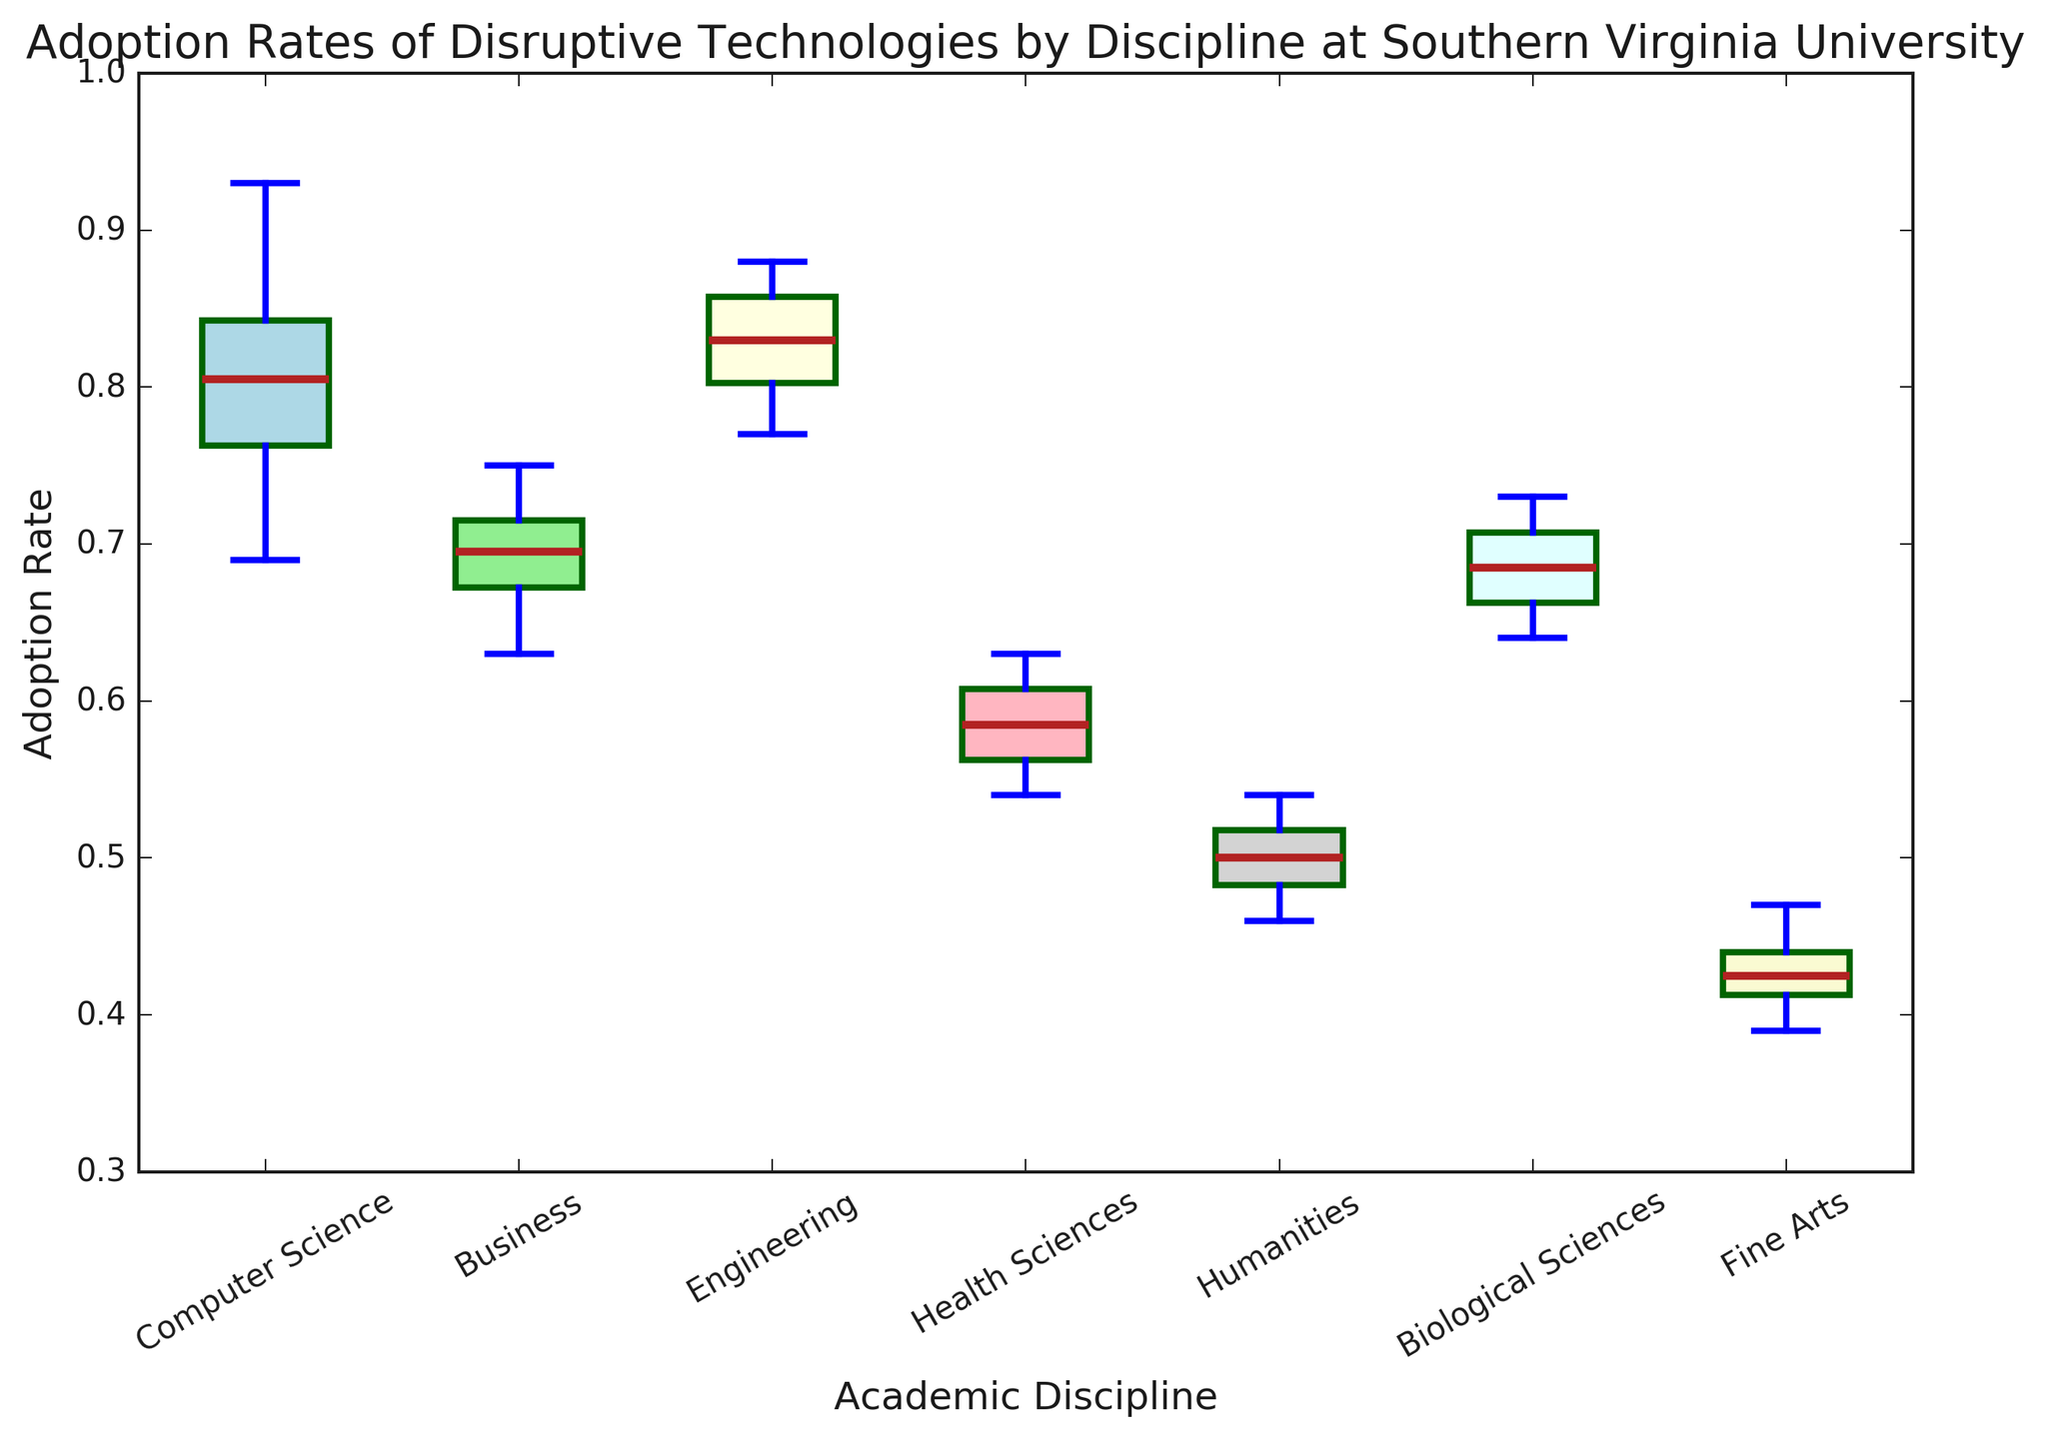Which academic discipline has the highest median adoption rate? By looking at the plot, find the median line for each box plot and compare their positions. The highest median is represented by the line in the Engineering box plot.
Answer: Engineering Which academic discipline has the lowest lower whisker? By observing all the whiskers of each box plot, the lowest whisker is visibly in the Fine Arts box plot.
Answer: Fine Arts What is the range of adoption rates in the Health Sciences discipline? The range is the difference between the top whisker and the bottom whisker of the Health Sciences box plot. The bottom whisker is 0.54, and the top whisker is 0.63. Therefore, the range is 0.63 - 0.54 = 0.09.
Answer: 0.09 Which discipline has the smallest interquartile range (IQR)? The IQR is the difference between the third quartile (Q3) and the first quartile (Q1) in the box plot. By looking at the lengths of the boxes, the smallest box is for Fine Arts.
Answer: Fine Arts Is the median adoption rate of Business discipline higher than that of Biological Sciences? Compare the median lines of the Business and Biological Sciences box plots. The Business box plot's median is 0.70, while Biological Sciences is 0.68. Thus, Business has a higher median.
Answer: Yes Which color represents the Computer Science box plot? By identifying the appropriate label and matching the color of the box plot, Computer Science is represented with the light blue color.
Answer: Light blue What is the average of the medians from the Humanities and Business disciplines? Find the median line values for both Humanities (0.50) and Business (0.70). The average of these two values is (0.50 + 0.70) / 2 = 0.60.
Answer: 0.60 How many disciplines have a median adoption rate below 0.70? Observe the median lines of all the box plots and count those below 0.70. The disciplines are Fine Arts, Humanities, Health Sciences, and Biological Sciences. Thus, there are 4 disciplines.
Answer: 4 Which discipline has the widest adoption rate spread from its first quartile to its maximum value? The spread from the first quartile (Q1) to the maximum value is the distance from the bottom of the box to the top whisker. By looking at the box plots, Computer Science has the widest spread.
Answer: Computer Science Which color box plot represents an academic discipline with a median below 0.55? Identify the box plots where the median line is below 0.55, which are Fine Arts and Humanities. Fine Arts is represented by light gray, and Humanities by light pink. Only these two satisfy the condition.
Answer: Light gray and light pink 